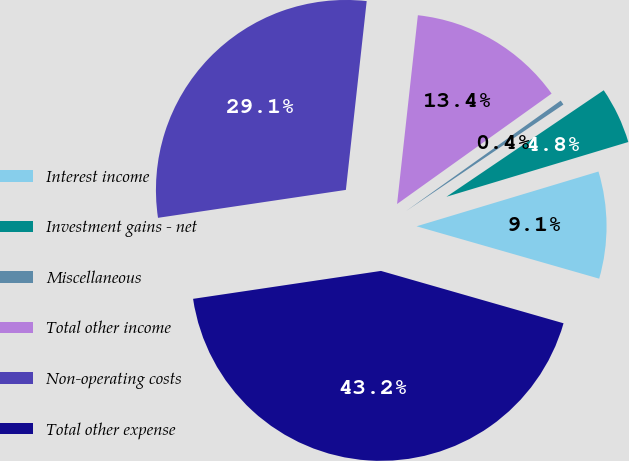Convert chart. <chart><loc_0><loc_0><loc_500><loc_500><pie_chart><fcel>Interest income<fcel>Investment gains - net<fcel>Miscellaneous<fcel>Total other income<fcel>Non-operating costs<fcel>Total other expense<nl><fcel>9.1%<fcel>4.82%<fcel>0.4%<fcel>13.38%<fcel>29.1%<fcel>43.21%<nl></chart> 